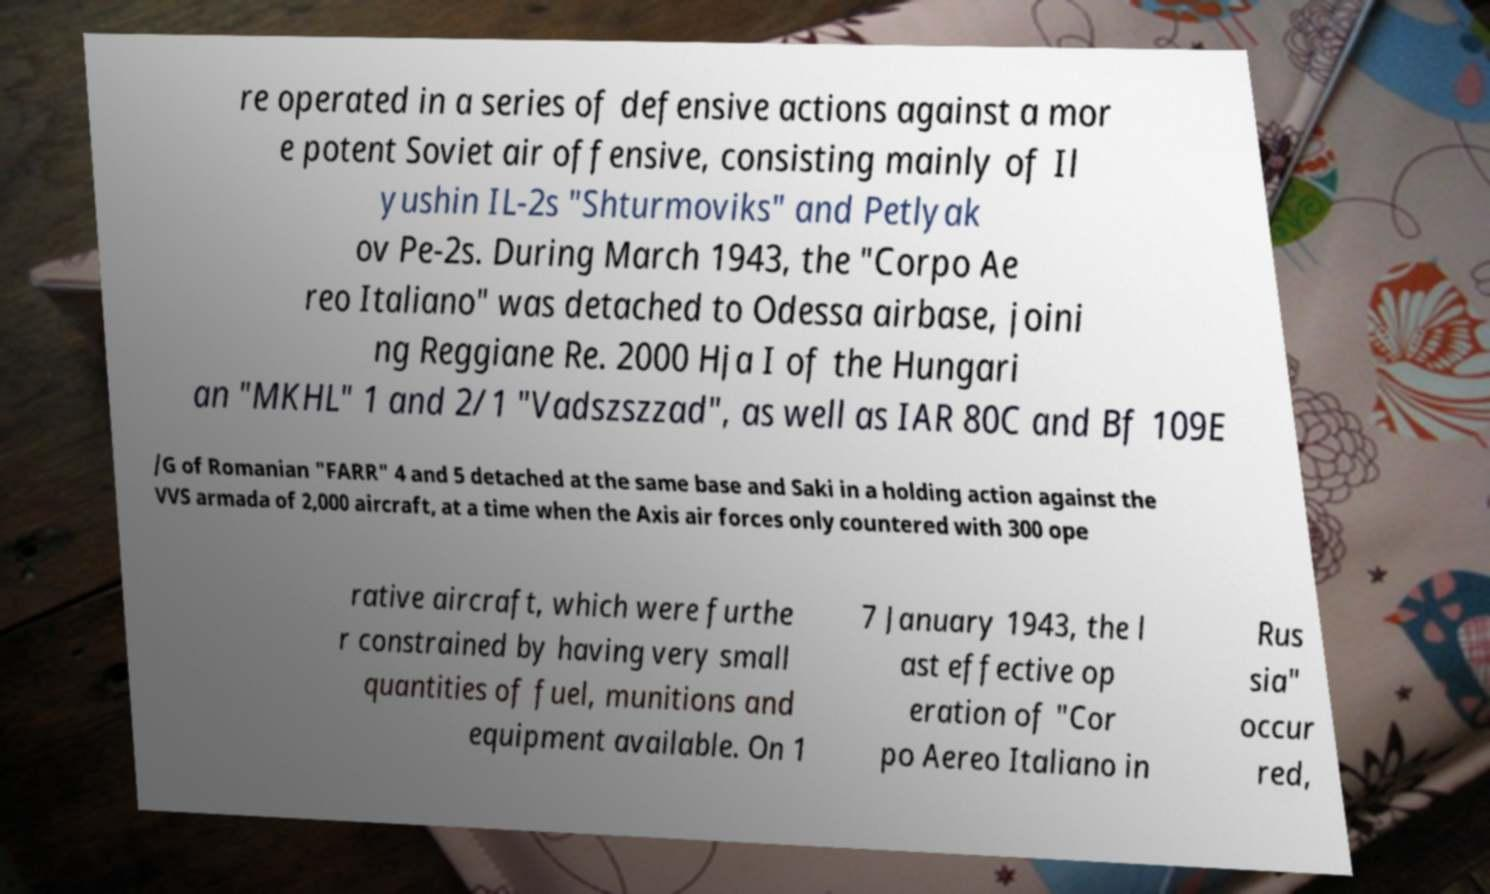What messages or text are displayed in this image? I need them in a readable, typed format. re operated in a series of defensive actions against a mor e potent Soviet air offensive, consisting mainly of Il yushin IL-2s "Shturmoviks" and Petlyak ov Pe-2s. During March 1943, the "Corpo Ae reo Italiano" was detached to Odessa airbase, joini ng Reggiane Re. 2000 Hja I of the Hungari an "MKHL" 1 and 2/1 "Vadszszzad", as well as IAR 80C and Bf 109E /G of Romanian "FARR" 4 and 5 detached at the same base and Saki in a holding action against the VVS armada of 2,000 aircraft, at a time when the Axis air forces only countered with 300 ope rative aircraft, which were furthe r constrained by having very small quantities of fuel, munitions and equipment available. On 1 7 January 1943, the l ast effective op eration of "Cor po Aereo Italiano in Rus sia" occur red, 